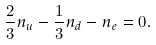<formula> <loc_0><loc_0><loc_500><loc_500>\frac { 2 } { 3 } n _ { u } - \frac { 1 } { 3 } n _ { d } - n _ { e } = 0 .</formula> 